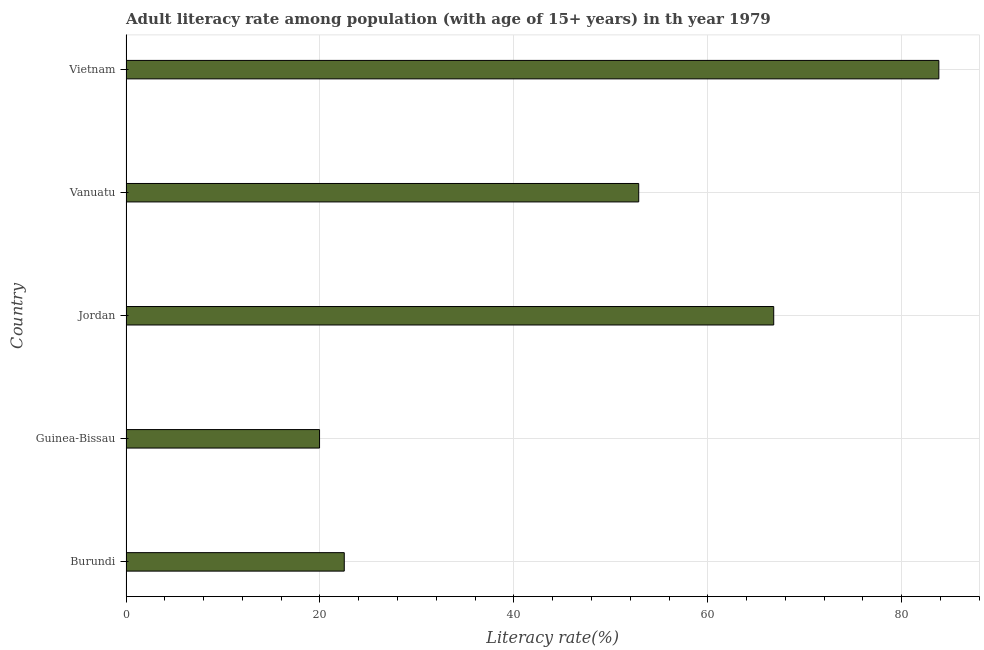What is the title of the graph?
Your answer should be very brief. Adult literacy rate among population (with age of 15+ years) in th year 1979. What is the label or title of the X-axis?
Ensure brevity in your answer.  Literacy rate(%). What is the adult literacy rate in Guinea-Bissau?
Provide a short and direct response. 19.96. Across all countries, what is the maximum adult literacy rate?
Provide a short and direct response. 83.83. Across all countries, what is the minimum adult literacy rate?
Offer a very short reply. 19.96. In which country was the adult literacy rate maximum?
Offer a terse response. Vietnam. In which country was the adult literacy rate minimum?
Offer a terse response. Guinea-Bissau. What is the sum of the adult literacy rate?
Give a very brief answer. 245.96. What is the difference between the adult literacy rate in Burundi and Vanuatu?
Keep it short and to the point. -30.36. What is the average adult literacy rate per country?
Provide a short and direct response. 49.19. What is the median adult literacy rate?
Make the answer very short. 52.87. What is the ratio of the adult literacy rate in Burundi to that in Jordan?
Your answer should be compact. 0.34. Is the difference between the adult literacy rate in Guinea-Bissau and Jordan greater than the difference between any two countries?
Keep it short and to the point. No. What is the difference between the highest and the second highest adult literacy rate?
Your response must be concise. 17.03. What is the difference between the highest and the lowest adult literacy rate?
Give a very brief answer. 63.87. Are all the bars in the graph horizontal?
Ensure brevity in your answer.  Yes. What is the difference between two consecutive major ticks on the X-axis?
Give a very brief answer. 20. Are the values on the major ticks of X-axis written in scientific E-notation?
Your response must be concise. No. What is the Literacy rate(%) of Burundi?
Your answer should be very brief. 22.51. What is the Literacy rate(%) of Guinea-Bissau?
Provide a short and direct response. 19.96. What is the Literacy rate(%) in Jordan?
Offer a terse response. 66.8. What is the Literacy rate(%) of Vanuatu?
Make the answer very short. 52.87. What is the Literacy rate(%) of Vietnam?
Your answer should be very brief. 83.83. What is the difference between the Literacy rate(%) in Burundi and Guinea-Bissau?
Your answer should be compact. 2.55. What is the difference between the Literacy rate(%) in Burundi and Jordan?
Your response must be concise. -44.29. What is the difference between the Literacy rate(%) in Burundi and Vanuatu?
Provide a short and direct response. -30.37. What is the difference between the Literacy rate(%) in Burundi and Vietnam?
Provide a short and direct response. -61.32. What is the difference between the Literacy rate(%) in Guinea-Bissau and Jordan?
Keep it short and to the point. -46.84. What is the difference between the Literacy rate(%) in Guinea-Bissau and Vanuatu?
Provide a succinct answer. -32.92. What is the difference between the Literacy rate(%) in Guinea-Bissau and Vietnam?
Your answer should be very brief. -63.87. What is the difference between the Literacy rate(%) in Jordan and Vanuatu?
Keep it short and to the point. 13.92. What is the difference between the Literacy rate(%) in Jordan and Vietnam?
Make the answer very short. -17.03. What is the difference between the Literacy rate(%) in Vanuatu and Vietnam?
Ensure brevity in your answer.  -30.95. What is the ratio of the Literacy rate(%) in Burundi to that in Guinea-Bissau?
Your answer should be compact. 1.13. What is the ratio of the Literacy rate(%) in Burundi to that in Jordan?
Make the answer very short. 0.34. What is the ratio of the Literacy rate(%) in Burundi to that in Vanuatu?
Provide a succinct answer. 0.43. What is the ratio of the Literacy rate(%) in Burundi to that in Vietnam?
Your response must be concise. 0.27. What is the ratio of the Literacy rate(%) in Guinea-Bissau to that in Jordan?
Your response must be concise. 0.3. What is the ratio of the Literacy rate(%) in Guinea-Bissau to that in Vanuatu?
Provide a succinct answer. 0.38. What is the ratio of the Literacy rate(%) in Guinea-Bissau to that in Vietnam?
Offer a terse response. 0.24. What is the ratio of the Literacy rate(%) in Jordan to that in Vanuatu?
Provide a succinct answer. 1.26. What is the ratio of the Literacy rate(%) in Jordan to that in Vietnam?
Give a very brief answer. 0.8. What is the ratio of the Literacy rate(%) in Vanuatu to that in Vietnam?
Your response must be concise. 0.63. 